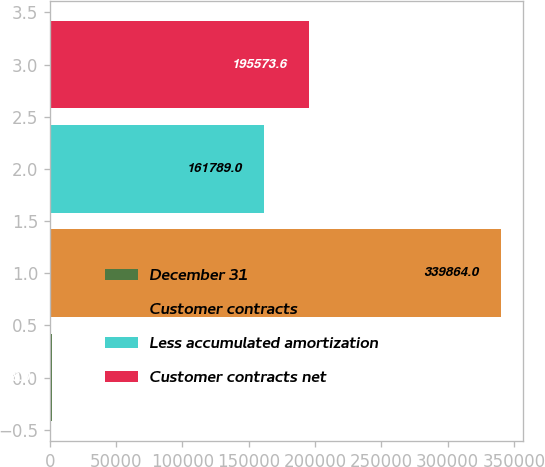Convert chart. <chart><loc_0><loc_0><loc_500><loc_500><bar_chart><fcel>December 31<fcel>Customer contracts<fcel>Less accumulated amortization<fcel>Customer contracts net<nl><fcel>2018<fcel>339864<fcel>161789<fcel>195574<nl></chart> 